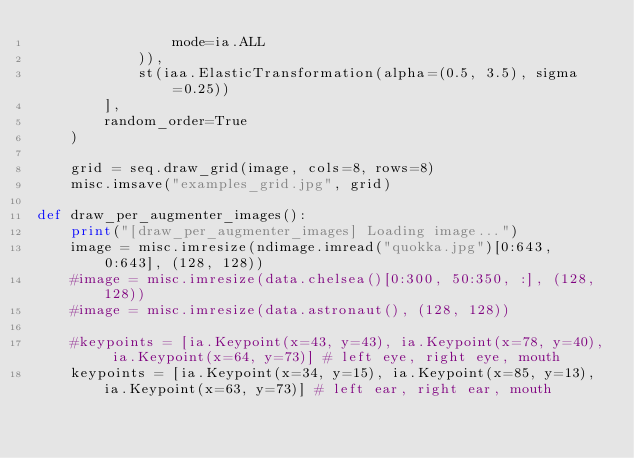Convert code to text. <code><loc_0><loc_0><loc_500><loc_500><_Python_>                mode=ia.ALL
            )),
            st(iaa.ElasticTransformation(alpha=(0.5, 3.5), sigma=0.25))
        ],
        random_order=True
    )

    grid = seq.draw_grid(image, cols=8, rows=8)
    misc.imsave("examples_grid.jpg", grid)

def draw_per_augmenter_images():
    print("[draw_per_augmenter_images] Loading image...")
    image = misc.imresize(ndimage.imread("quokka.jpg")[0:643, 0:643], (128, 128))
    #image = misc.imresize(data.chelsea()[0:300, 50:350, :], (128, 128))
    #image = misc.imresize(data.astronaut(), (128, 128))

    #keypoints = [ia.Keypoint(x=43, y=43), ia.Keypoint(x=78, y=40), ia.Keypoint(x=64, y=73)] # left eye, right eye, mouth
    keypoints = [ia.Keypoint(x=34, y=15), ia.Keypoint(x=85, y=13), ia.Keypoint(x=63, y=73)] # left ear, right ear, mouth</code> 